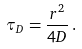<formula> <loc_0><loc_0><loc_500><loc_500>\tau _ { D } = \frac { r ^ { 2 } } { 4 D } \, .</formula> 